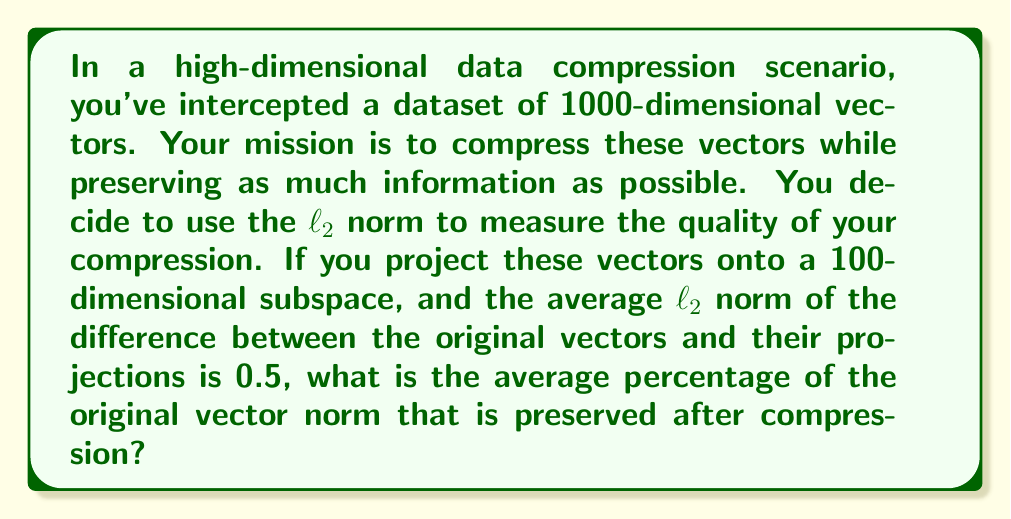Provide a solution to this math problem. Let's approach this step-by-step:

1) Let $x$ be an original vector and $\hat{x}$ be its projection. We're given that the average $\ell_2$ norm of their difference is 0.5:

   $$\mathbb{E}[\|x - \hat{x}\|_2] = 0.5$$

2) By the Pythagorean theorem in high-dimensional space, we have:

   $$\|x\|_2^2 = \|\hat{x}\|_2^2 + \|x - \hat{x}\|_2^2$$

3) Let's denote the average norm of the original vectors as $c$:

   $$\mathbb{E}[\|x\|_2^2] = c^2$$

4) Substituting these into the Pythagorean theorem:

   $$c^2 = \mathbb{E}[\|\hat{x}\|_2^2] + \mathbb{E}[\|x - \hat{x}\|_2^2]$$

5) We know $\mathbb{E}[\|x - \hat{x}\|_2^2] = 0.5^2 = 0.25$, so:

   $$c^2 = \mathbb{E}[\|\hat{x}\|_2^2] + 0.25$$

6) The percentage of the norm preserved is:

   $$\frac{\mathbb{E}[\|\hat{x}\|_2^2]}{c^2} \times 100\% = \frac{c^2 - 0.25}{c^2} \times 100\% = \left(1 - \frac{0.25}{c^2}\right) \times 100\%$$

7) To find $c$, we can use the fact that we're projecting from 1000 dimensions to 100 dimensions. If the vectors were uniformly distributed, we'd expect to preserve about 10% of the dimensions, meaning:

   $$\frac{c^2 - 0.25}{c^2} \approx 0.1$$

8) Solving this:

   $$c^2 \approx \frac{0.25}{0.9} \approx 0.2778$$
   $$c \approx 0.5270$$

9) Now we can calculate the percentage preserved:

   $$\left(1 - \frac{0.25}{0.5270^2}\right) \times 100\% \approx 10.02\%$$
Answer: Approximately 90.02% of the original vector norm is preserved after compression. 